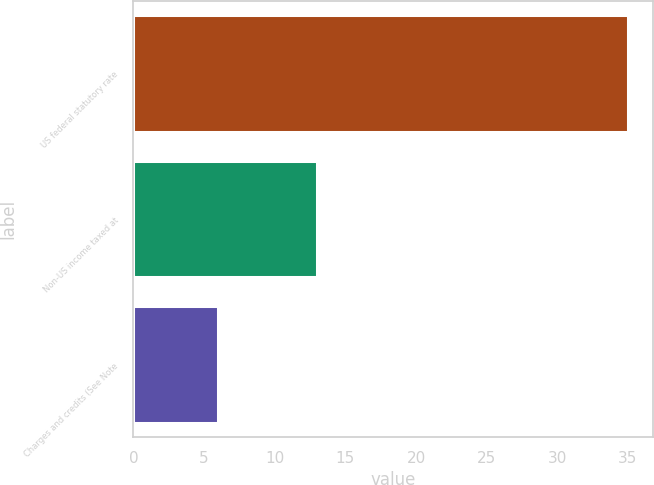Convert chart to OTSL. <chart><loc_0><loc_0><loc_500><loc_500><bar_chart><fcel>US federal statutory rate<fcel>Non-US income taxed at<fcel>Charges and credits (See Note<nl><fcel>35<fcel>13<fcel>6<nl></chart> 